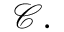<formula> <loc_0><loc_0><loc_500><loc_500>\mathcal { C } .</formula> 